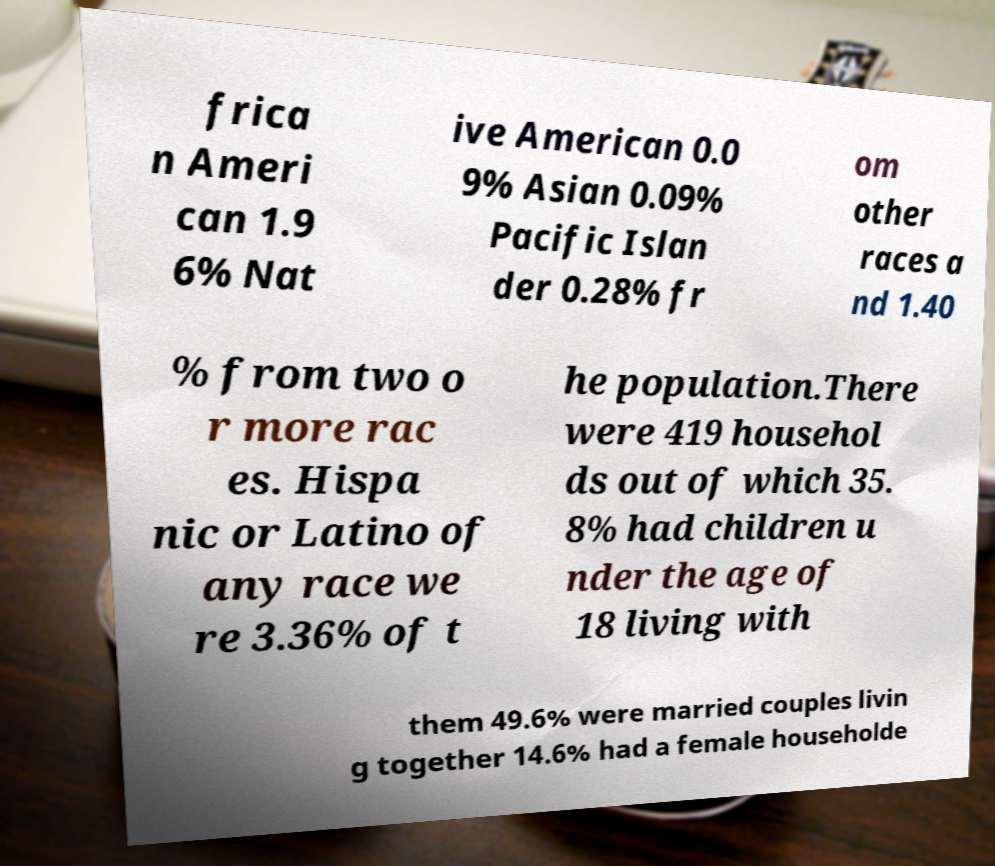I need the written content from this picture converted into text. Can you do that? frica n Ameri can 1.9 6% Nat ive American 0.0 9% Asian 0.09% Pacific Islan der 0.28% fr om other races a nd 1.40 % from two o r more rac es. Hispa nic or Latino of any race we re 3.36% of t he population.There were 419 househol ds out of which 35. 8% had children u nder the age of 18 living with them 49.6% were married couples livin g together 14.6% had a female householde 